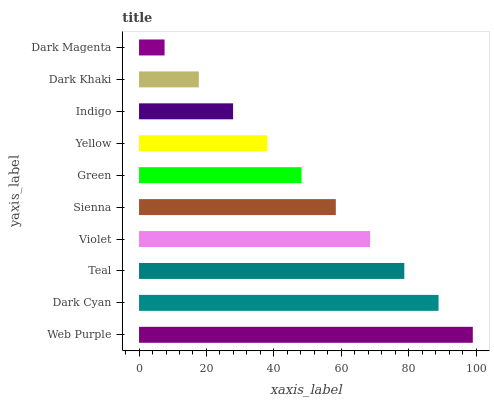Is Dark Magenta the minimum?
Answer yes or no. Yes. Is Web Purple the maximum?
Answer yes or no. Yes. Is Dark Cyan the minimum?
Answer yes or no. No. Is Dark Cyan the maximum?
Answer yes or no. No. Is Web Purple greater than Dark Cyan?
Answer yes or no. Yes. Is Dark Cyan less than Web Purple?
Answer yes or no. Yes. Is Dark Cyan greater than Web Purple?
Answer yes or no. No. Is Web Purple less than Dark Cyan?
Answer yes or no. No. Is Sienna the high median?
Answer yes or no. Yes. Is Green the low median?
Answer yes or no. Yes. Is Dark Khaki the high median?
Answer yes or no. No. Is Dark Khaki the low median?
Answer yes or no. No. 